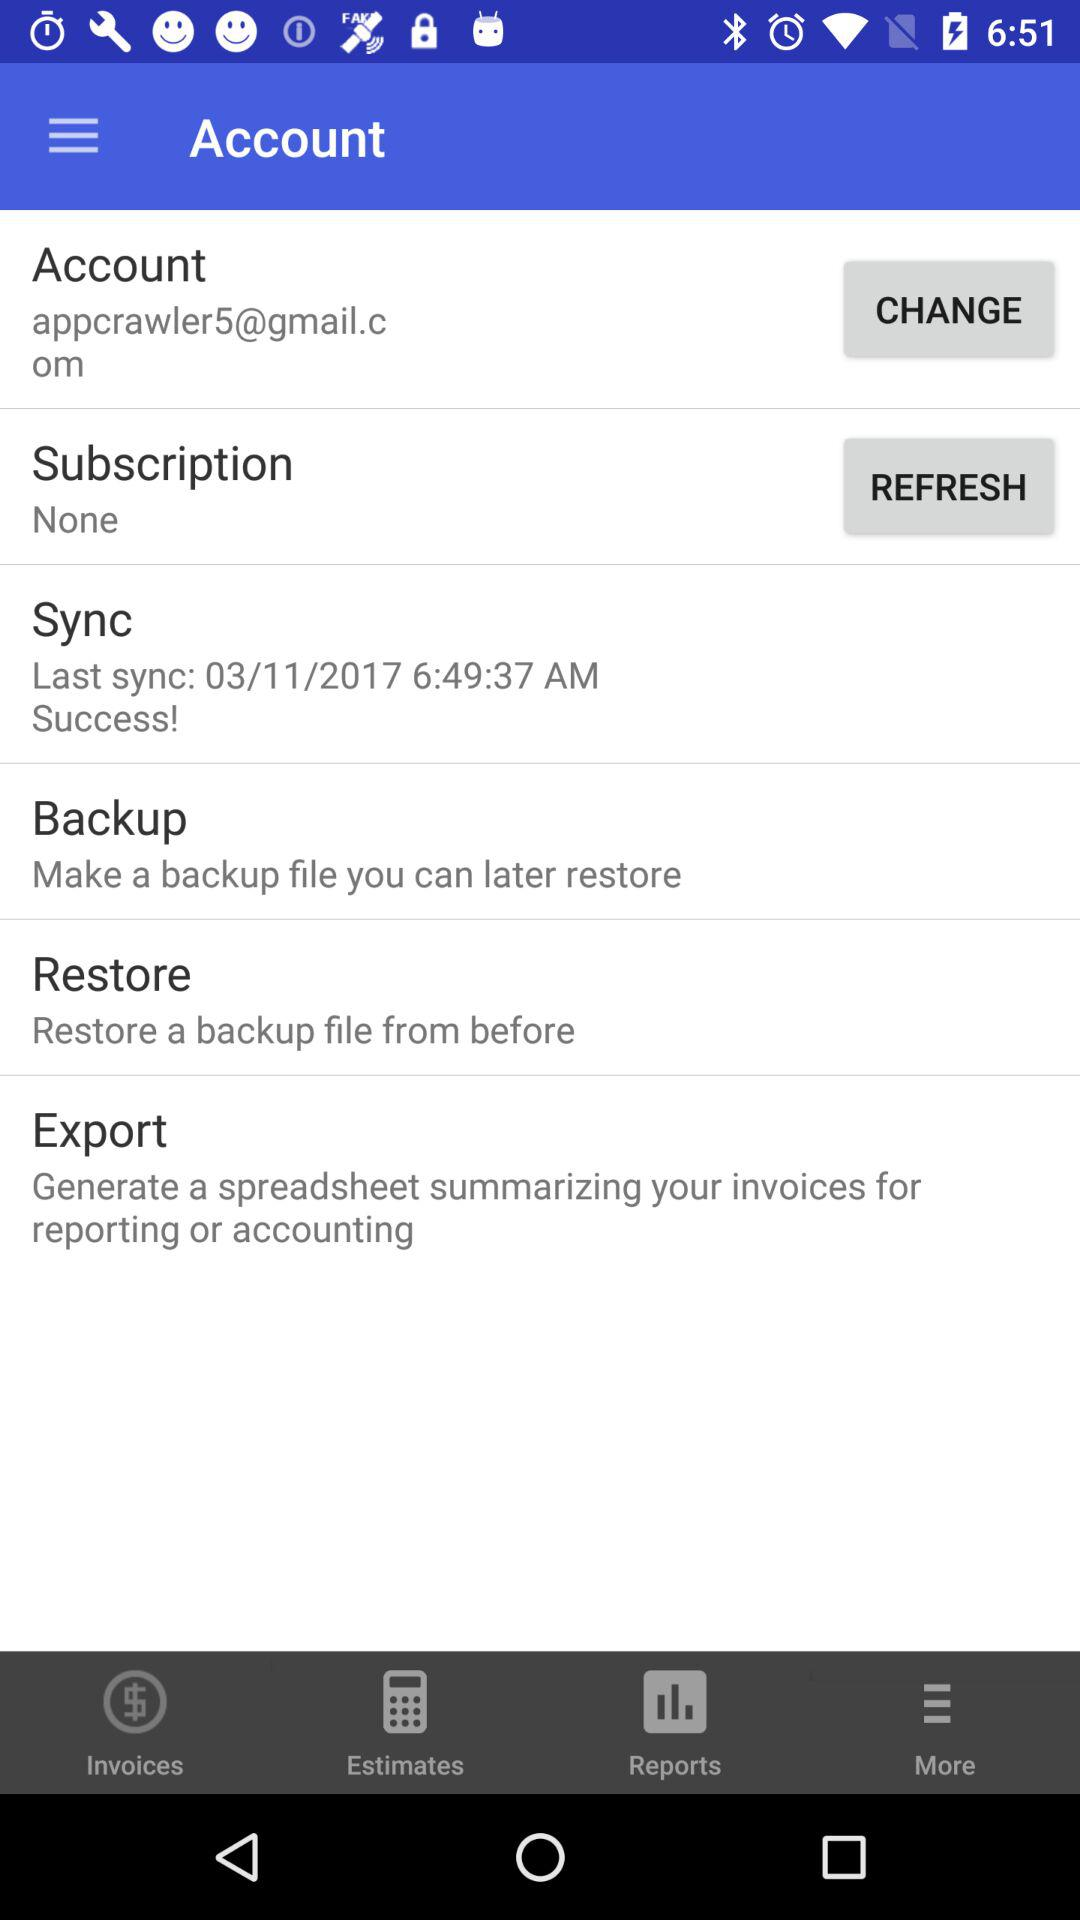What is the subscription type? The subscription type is "None". 